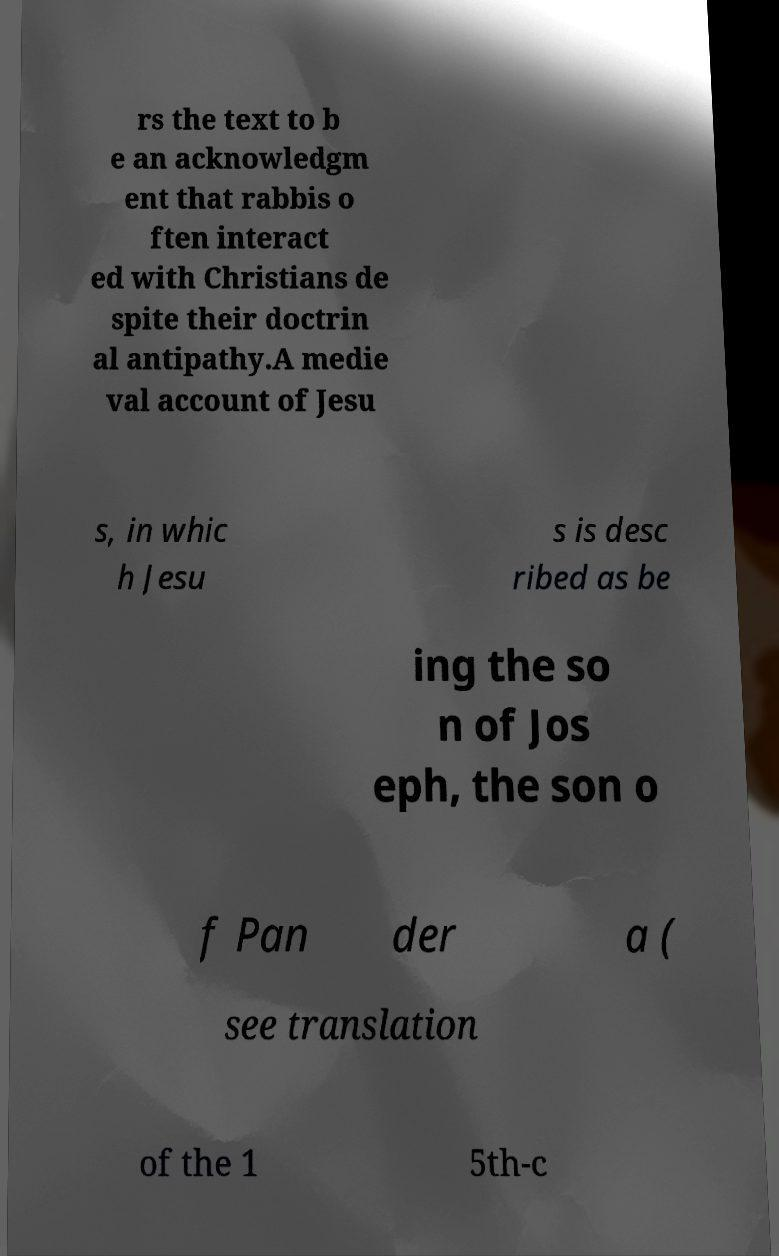Could you extract and type out the text from this image? rs the text to b e an acknowledgm ent that rabbis o ften interact ed with Christians de spite their doctrin al antipathy.A medie val account of Jesu s, in whic h Jesu s is desc ribed as be ing the so n of Jos eph, the son o f Pan der a ( see translation of the 1 5th-c 